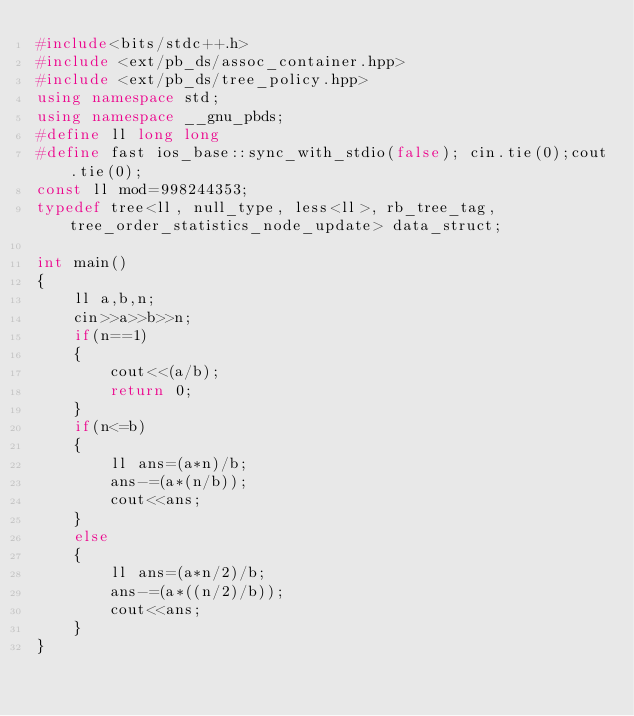<code> <loc_0><loc_0><loc_500><loc_500><_C++_>#include<bits/stdc++.h>
#include <ext/pb_ds/assoc_container.hpp>
#include <ext/pb_ds/tree_policy.hpp>
using namespace std;
using namespace __gnu_pbds;
#define ll long long 
#define fast ios_base::sync_with_stdio(false); cin.tie(0);cout.tie(0);
const ll mod=998244353;
typedef tree<ll, null_type, less<ll>, rb_tree_tag, tree_order_statistics_node_update> data_struct;

int main()
{
	ll a,b,n;
	cin>>a>>b>>n;
	if(n==1)
	{
		cout<<(a/b);
		return 0;
	}
	if(n<=b)
	{
		ll ans=(a*n)/b;
		ans-=(a*(n/b));
		cout<<ans;
	}
	else
	{
		ll ans=(a*n/2)/b;
		ans-=(a*((n/2)/b));
		cout<<ans;
	}
}</code> 